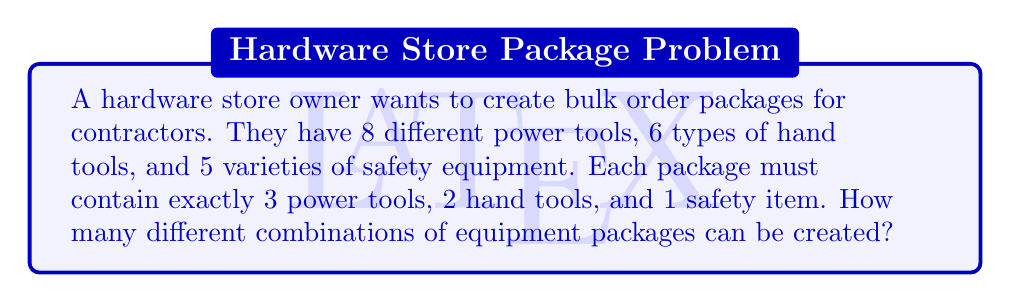Teach me how to tackle this problem. Let's break this down step-by-step:

1) For power tools:
   We need to choose 3 out of 8 power tools. This is a combination problem.
   Number of ways to choose power tools = $\binom{8}{3}$

2) For hand tools:
   We need to choose 2 out of 6 hand tools.
   Number of ways to choose hand tools = $\binom{6}{2}$

3) For safety equipment:
   We need to choose 1 out of 5 safety items.
   Number of ways to choose safety equipment = $\binom{5}{1}$

4) To calculate each combination:
   $\binom{8}{3} = \frac{8!}{3!(8-3)!} = \frac{8!}{3!5!} = 56$
   $\binom{6}{2} = \frac{6!}{2!(6-2)!} = \frac{6!}{2!4!} = 15$
   $\binom{5}{1} = \frac{5!}{1!(5-1)!} = \frac{5!}{1!4!} = 5$

5) By the multiplication principle, the total number of possible combinations is:
   $56 \times 15 \times 5 = 4,200$

Therefore, the hardware store owner can create 4,200 different combinations of equipment packages for bulk orders.
Answer: 4,200 combinations 